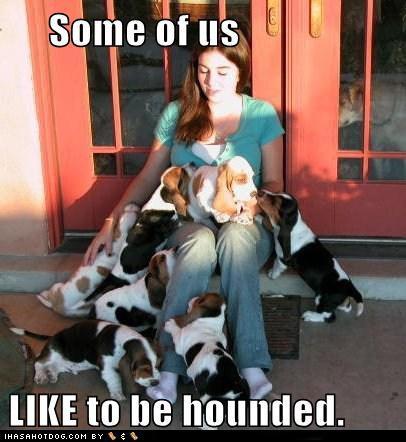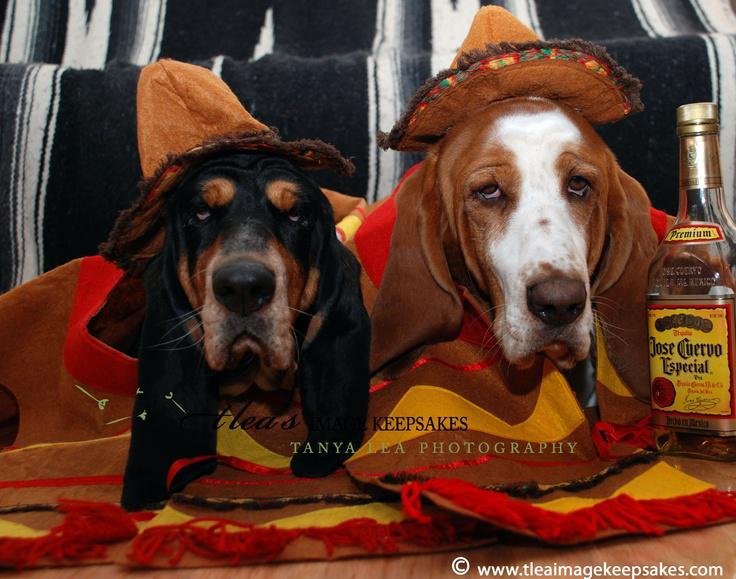The first image is the image on the left, the second image is the image on the right. Examine the images to the left and right. Is the description "There are two dogs in total." accurate? Answer yes or no. No. The first image is the image on the left, the second image is the image on the right. Assess this claim about the two images: "An image shows at least one dog wearing a hat associated with an ingestible product that is also pictured.". Correct or not? Answer yes or no. Yes. 